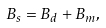<formula> <loc_0><loc_0><loc_500><loc_500>B _ { s } = B _ { d } + B _ { m } ,</formula> 